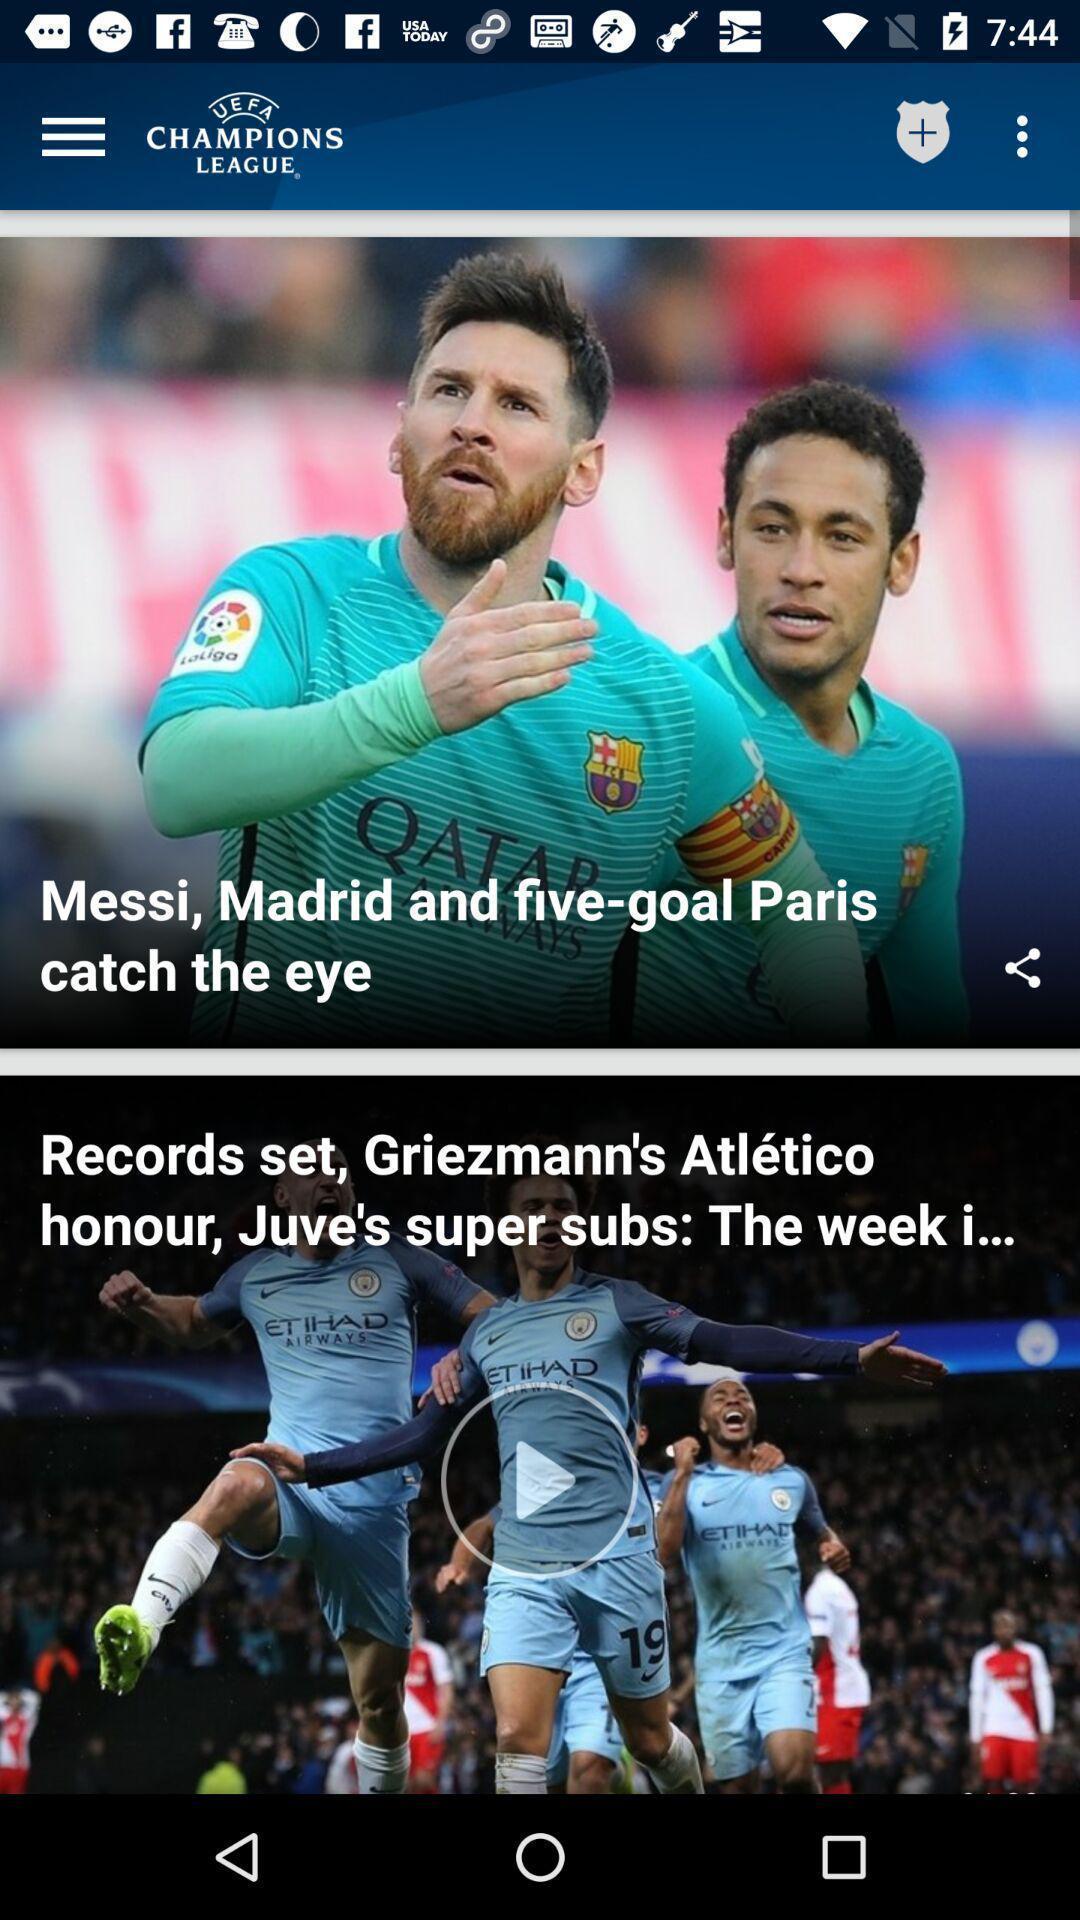What can you discern from this picture? Page displaying sports news. 